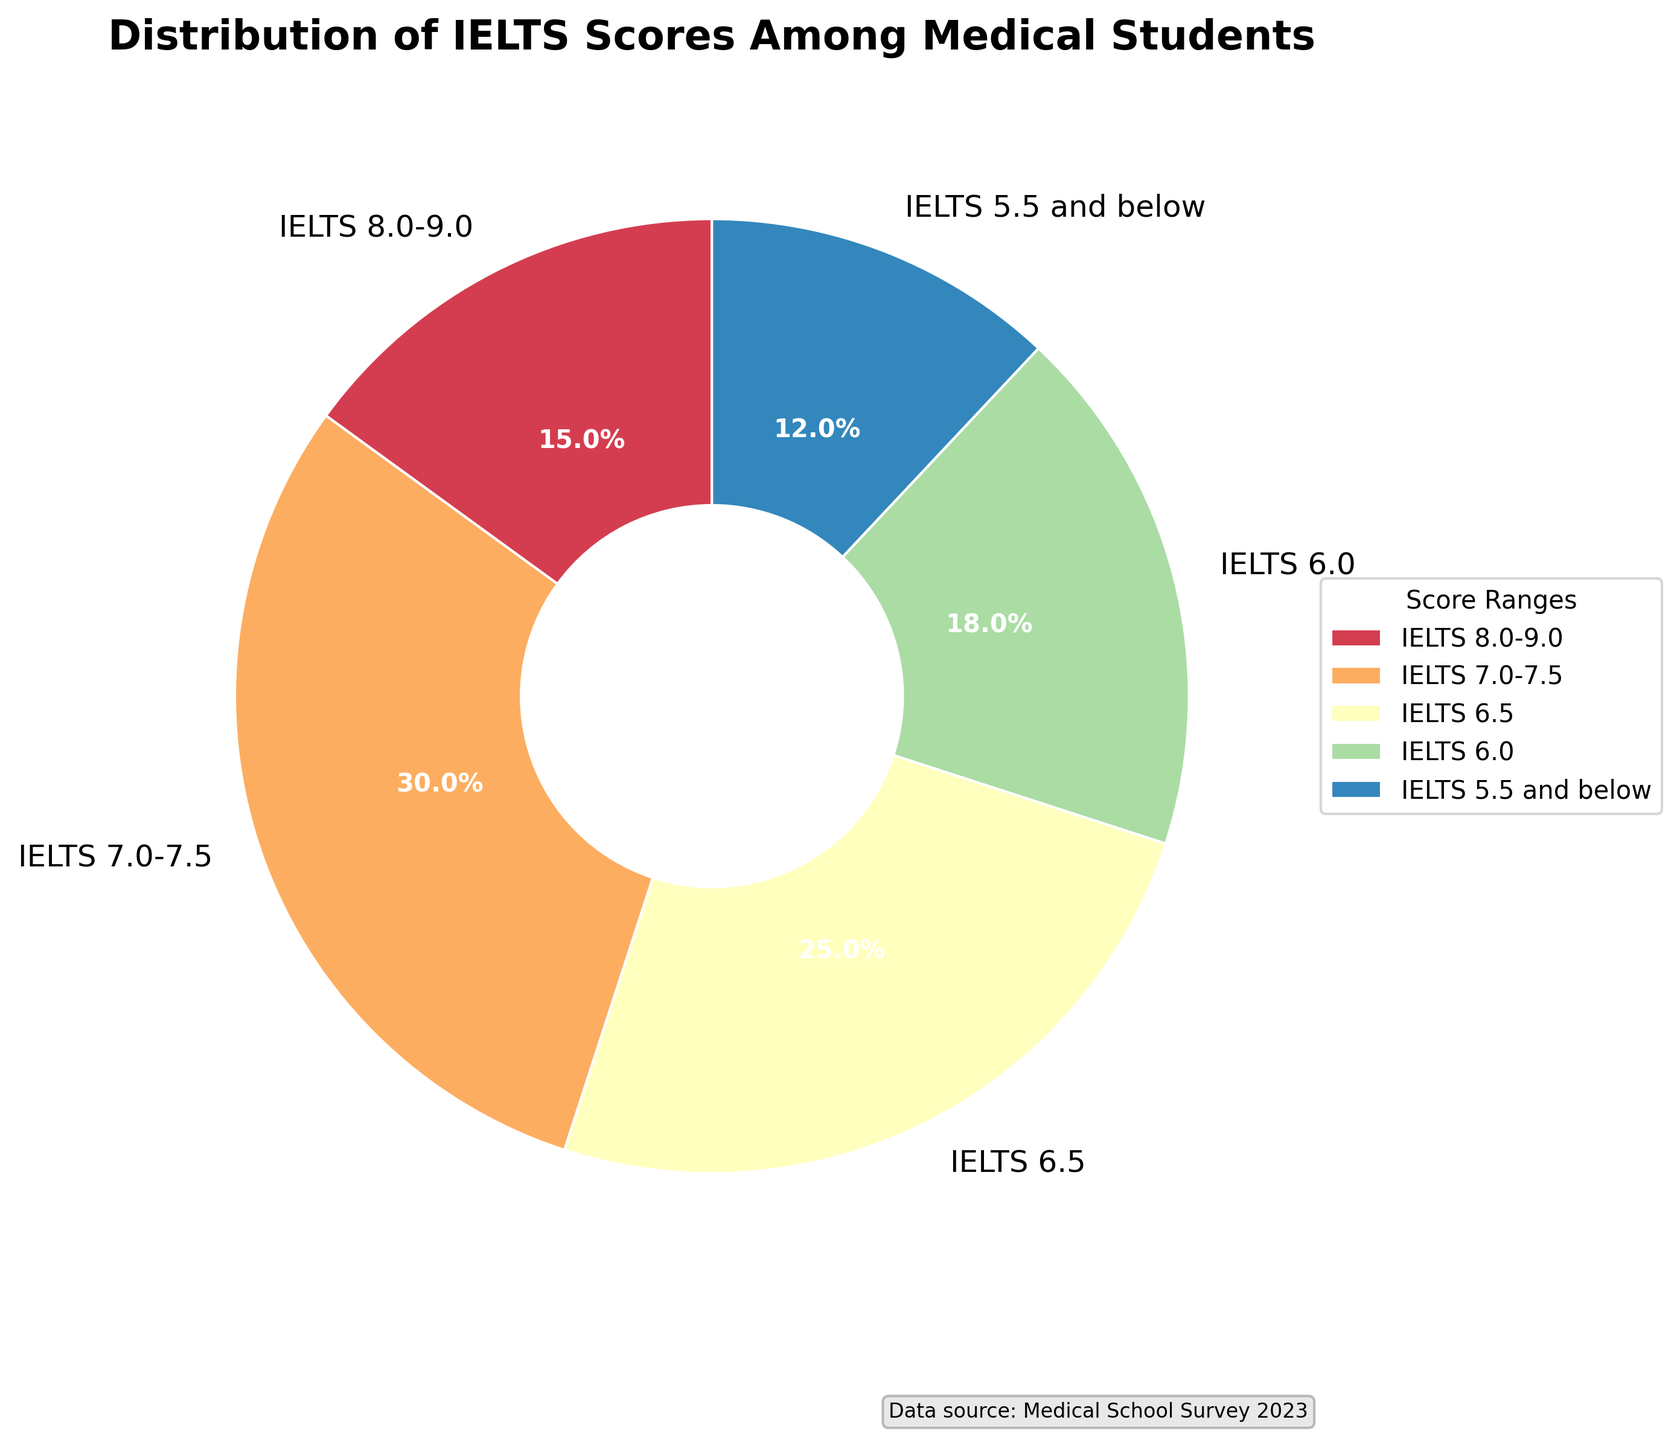What is the percentage of students who scored 8.0-9.0 on the IELTS? The figure shows a pie chart with various IELTS score ranges and their corresponding percentages. The section labeled "IELTS 8.0-9.0" has a percentage value of 15% indicated on it.
Answer: 15% Which group has the highest percentage of students? By observing the pie chart, we can compare the different segments. The segment labeled "IELTS 7.0-7.5" has the highest percentage, which is 30%.
Answer: IELTS 7.0-7.5 What percentage of students scored 6.5 or below on the IELTS? To find this, sum the percentages for "IELTS 6.5" (25%), "IELTS 6.0" (18%), and "IELTS 5.5 and below" (12%). The total is 25% + 18% + 12% = 55%.
Answer: 55% How does the percentage of students scoring 6.0 compare to those scoring 8.0-9.0? The segment for "IELTS 6.0" indicates 18%, and the segment for "IELTS 8.0-9.0" indicates 15%. Thus, 18% is greater than 15%.
Answer: 18% > 15% What is the combined percentage of students who scored either 7.0-7.5 or 8.0-9.0? Sum the percentages for "IELTS 7.0-7.5" (30%) and "IELTS 8.0-9.0" (15%). The total is 30% + 15% = 45%.
Answer: 45% Which score range has the smallest proportion of students? By examining the pie chart, the segment labeled "IELTS 5.5 and below" has the smallest percentage, which is 12%.
Answer: IELTS 5.5 and below Among the students who scored 6.0 and 6.5, who has a higher percentage, and by how much? The segment for "IELTS 6.5" shows 25%, and the segment for "IELTS 6.0" shows 18%. The difference is 25% - 18% = 7%.
Answer: IELTS 6.5 by 7% What is the difference in percentage between the highest and lowest scoring groups? The highest percentage is for "IELTS 7.0-7.5" at 30%, and the lowest is for "IELTS 5.5 and below" at 12%. The difference is 30% - 12% = 18%.
Answer: 18% If 200 students were surveyed, how many scored 6.5? About 25% of 200 students scored 6.5. Calculate 25% of 200 by (25/100) * 200 = 50.
Answer: 50 